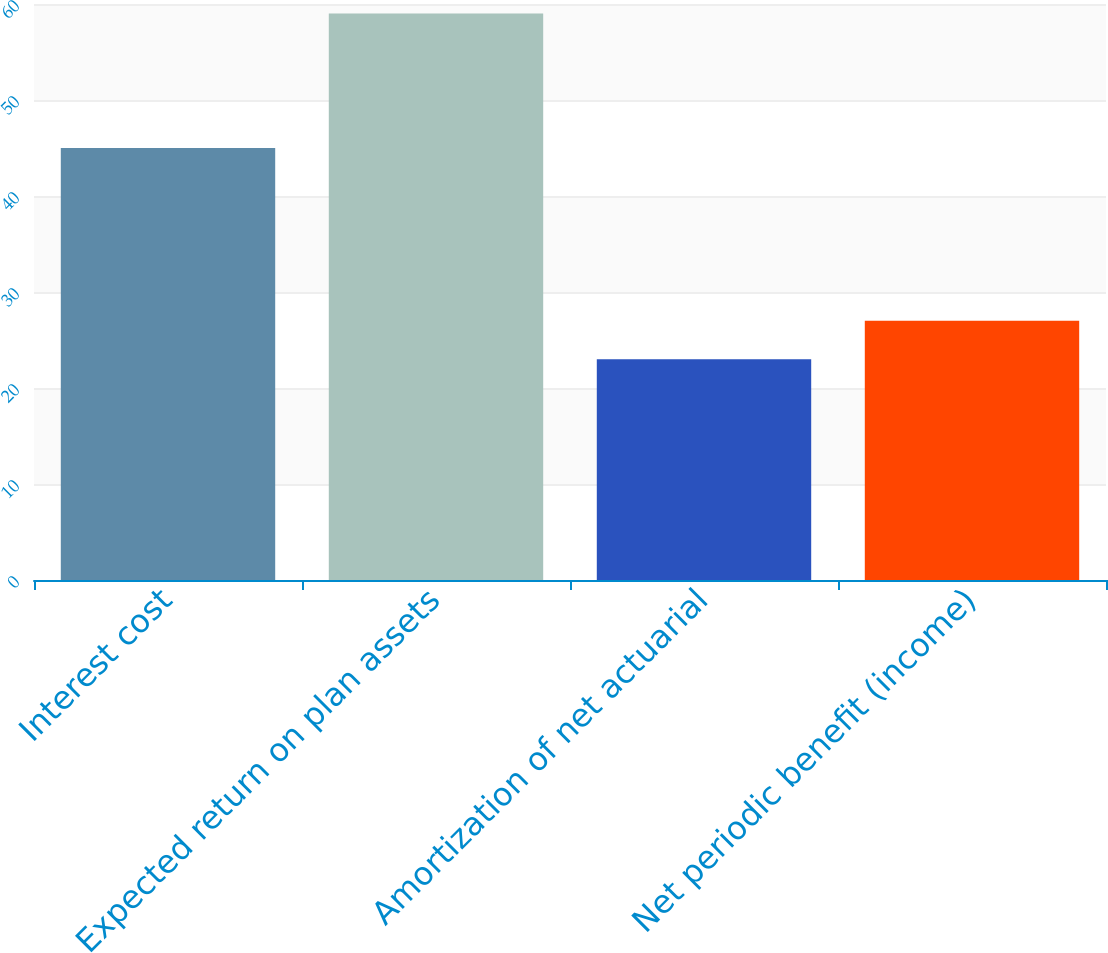<chart> <loc_0><loc_0><loc_500><loc_500><bar_chart><fcel>Interest cost<fcel>Expected return on plan assets<fcel>Amortization of net actuarial<fcel>Net periodic benefit (income)<nl><fcel>45<fcel>59<fcel>23<fcel>27<nl></chart> 